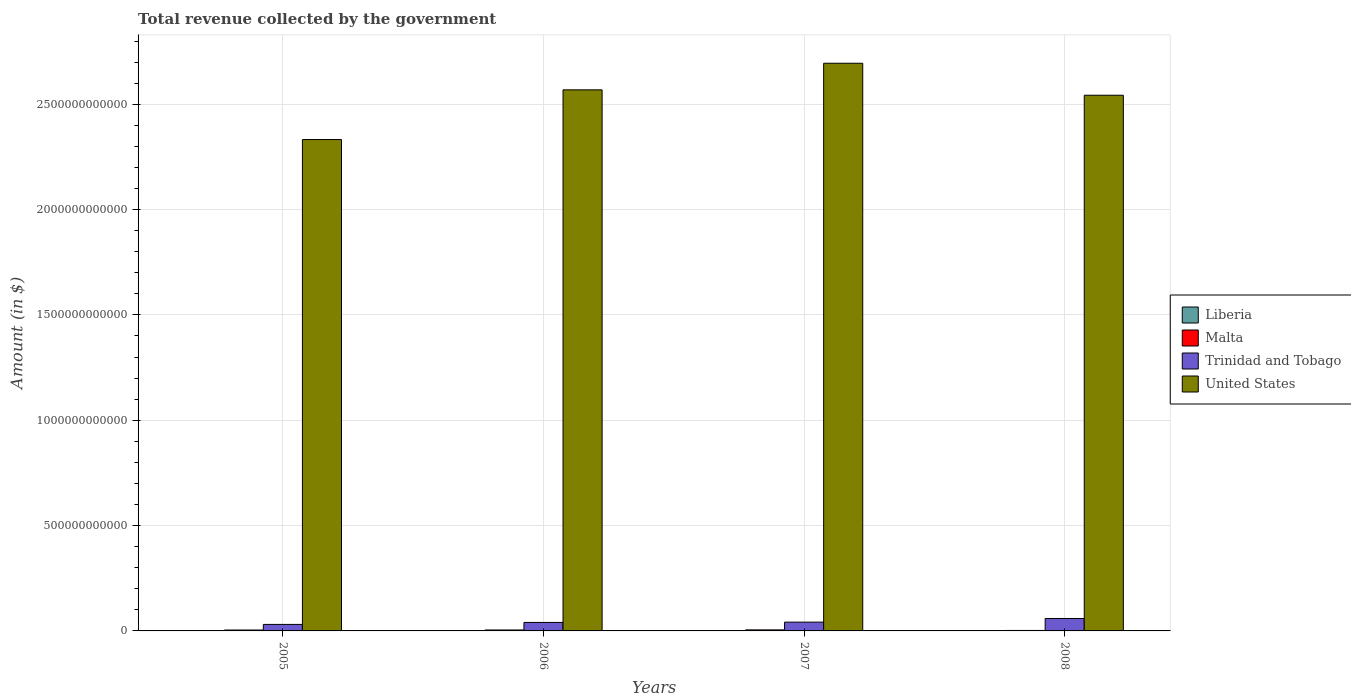How many groups of bars are there?
Offer a very short reply. 4. What is the label of the 1st group of bars from the left?
Your answer should be compact. 2005. What is the total revenue collected by the government in United States in 2007?
Provide a succinct answer. 2.69e+12. Across all years, what is the maximum total revenue collected by the government in Trinidad and Tobago?
Give a very brief answer. 5.90e+1. Across all years, what is the minimum total revenue collected by the government in United States?
Provide a succinct answer. 2.33e+12. What is the total total revenue collected by the government in United States in the graph?
Your response must be concise. 1.01e+13. What is the difference between the total revenue collected by the government in United States in 2005 and that in 2006?
Provide a short and direct response. -2.36e+11. What is the difference between the total revenue collected by the government in Trinidad and Tobago in 2007 and the total revenue collected by the government in Liberia in 2006?
Ensure brevity in your answer.  4.17e+1. What is the average total revenue collected by the government in Malta per year?
Your answer should be compact. 3.98e+09. In the year 2007, what is the difference between the total revenue collected by the government in United States and total revenue collected by the government in Malta?
Give a very brief answer. 2.69e+12. In how many years, is the total revenue collected by the government in United States greater than 1600000000000 $?
Make the answer very short. 4. What is the ratio of the total revenue collected by the government in Malta in 2005 to that in 2008?
Your answer should be compact. 1.89. Is the total revenue collected by the government in Malta in 2005 less than that in 2008?
Offer a very short reply. No. What is the difference between the highest and the second highest total revenue collected by the government in Malta?
Offer a very short reply. 4.26e+08. What is the difference between the highest and the lowest total revenue collected by the government in Trinidad and Tobago?
Offer a very short reply. 2.81e+1. In how many years, is the total revenue collected by the government in Liberia greater than the average total revenue collected by the government in Liberia taken over all years?
Your answer should be compact. 2. Is the sum of the total revenue collected by the government in Liberia in 2006 and 2007 greater than the maximum total revenue collected by the government in United States across all years?
Provide a succinct answer. No. Is it the case that in every year, the sum of the total revenue collected by the government in Liberia and total revenue collected by the government in Malta is greater than the sum of total revenue collected by the government in Trinidad and Tobago and total revenue collected by the government in United States?
Your answer should be compact. No. What does the 2nd bar from the left in 2005 represents?
Make the answer very short. Malta. Is it the case that in every year, the sum of the total revenue collected by the government in United States and total revenue collected by the government in Trinidad and Tobago is greater than the total revenue collected by the government in Malta?
Provide a short and direct response. Yes. How many bars are there?
Offer a terse response. 16. What is the difference between two consecutive major ticks on the Y-axis?
Offer a terse response. 5.00e+11. Does the graph contain any zero values?
Offer a terse response. No. Where does the legend appear in the graph?
Provide a succinct answer. Center right. How are the legend labels stacked?
Your answer should be very brief. Vertical. What is the title of the graph?
Offer a very short reply. Total revenue collected by the government. What is the label or title of the Y-axis?
Give a very brief answer. Amount (in $). What is the Amount (in $) in Liberia in 2005?
Offer a terse response. 1.39e+06. What is the Amount (in $) in Malta in 2005?
Offer a terse response. 4.23e+09. What is the Amount (in $) of Trinidad and Tobago in 2005?
Keep it short and to the point. 3.09e+1. What is the Amount (in $) in United States in 2005?
Make the answer very short. 2.33e+12. What is the Amount (in $) in Liberia in 2006?
Your answer should be very brief. 1.46e+06. What is the Amount (in $) in Malta in 2006?
Provide a succinct answer. 4.51e+09. What is the Amount (in $) in Trinidad and Tobago in 2006?
Give a very brief answer. 4.03e+1. What is the Amount (in $) in United States in 2006?
Offer a terse response. 2.57e+12. What is the Amount (in $) in Liberia in 2007?
Provide a succinct answer. 2.40e+06. What is the Amount (in $) of Malta in 2007?
Your answer should be very brief. 4.93e+09. What is the Amount (in $) in Trinidad and Tobago in 2007?
Offer a very short reply. 4.17e+1. What is the Amount (in $) in United States in 2007?
Ensure brevity in your answer.  2.69e+12. What is the Amount (in $) of Liberia in 2008?
Provide a short and direct response. 3.18e+06. What is the Amount (in $) in Malta in 2008?
Offer a very short reply. 2.24e+09. What is the Amount (in $) of Trinidad and Tobago in 2008?
Provide a short and direct response. 5.90e+1. What is the Amount (in $) of United States in 2008?
Provide a succinct answer. 2.54e+12. Across all years, what is the maximum Amount (in $) in Liberia?
Your response must be concise. 3.18e+06. Across all years, what is the maximum Amount (in $) of Malta?
Give a very brief answer. 4.93e+09. Across all years, what is the maximum Amount (in $) of Trinidad and Tobago?
Your answer should be compact. 5.90e+1. Across all years, what is the maximum Amount (in $) in United States?
Offer a terse response. 2.69e+12. Across all years, what is the minimum Amount (in $) of Liberia?
Your answer should be very brief. 1.39e+06. Across all years, what is the minimum Amount (in $) of Malta?
Ensure brevity in your answer.  2.24e+09. Across all years, what is the minimum Amount (in $) in Trinidad and Tobago?
Your answer should be compact. 3.09e+1. Across all years, what is the minimum Amount (in $) of United States?
Provide a succinct answer. 2.33e+12. What is the total Amount (in $) of Liberia in the graph?
Your answer should be compact. 8.43e+06. What is the total Amount (in $) in Malta in the graph?
Offer a terse response. 1.59e+1. What is the total Amount (in $) of Trinidad and Tobago in the graph?
Ensure brevity in your answer.  1.72e+11. What is the total Amount (in $) of United States in the graph?
Your response must be concise. 1.01e+13. What is the difference between the Amount (in $) in Liberia in 2005 and that in 2006?
Keep it short and to the point. -6.64e+04. What is the difference between the Amount (in $) of Malta in 2005 and that in 2006?
Your response must be concise. -2.75e+08. What is the difference between the Amount (in $) of Trinidad and Tobago in 2005 and that in 2006?
Give a very brief answer. -9.45e+09. What is the difference between the Amount (in $) in United States in 2005 and that in 2006?
Offer a very short reply. -2.36e+11. What is the difference between the Amount (in $) of Liberia in 2005 and that in 2007?
Your response must be concise. -1.01e+06. What is the difference between the Amount (in $) of Malta in 2005 and that in 2007?
Give a very brief answer. -7.01e+08. What is the difference between the Amount (in $) of Trinidad and Tobago in 2005 and that in 2007?
Keep it short and to the point. -1.08e+1. What is the difference between the Amount (in $) in United States in 2005 and that in 2007?
Keep it short and to the point. -3.62e+11. What is the difference between the Amount (in $) in Liberia in 2005 and that in 2008?
Offer a very short reply. -1.79e+06. What is the difference between the Amount (in $) in Malta in 2005 and that in 2008?
Ensure brevity in your answer.  1.99e+09. What is the difference between the Amount (in $) of Trinidad and Tobago in 2005 and that in 2008?
Keep it short and to the point. -2.81e+1. What is the difference between the Amount (in $) of United States in 2005 and that in 2008?
Keep it short and to the point. -2.10e+11. What is the difference between the Amount (in $) of Liberia in 2006 and that in 2007?
Provide a short and direct response. -9.40e+05. What is the difference between the Amount (in $) in Malta in 2006 and that in 2007?
Give a very brief answer. -4.26e+08. What is the difference between the Amount (in $) in Trinidad and Tobago in 2006 and that in 2007?
Give a very brief answer. -1.38e+09. What is the difference between the Amount (in $) of United States in 2006 and that in 2007?
Your response must be concise. -1.26e+11. What is the difference between the Amount (in $) of Liberia in 2006 and that in 2008?
Ensure brevity in your answer.  -1.73e+06. What is the difference between the Amount (in $) in Malta in 2006 and that in 2008?
Keep it short and to the point. 2.27e+09. What is the difference between the Amount (in $) of Trinidad and Tobago in 2006 and that in 2008?
Offer a terse response. -1.87e+1. What is the difference between the Amount (in $) in United States in 2006 and that in 2008?
Give a very brief answer. 2.56e+1. What is the difference between the Amount (in $) in Liberia in 2007 and that in 2008?
Offer a terse response. -7.87e+05. What is the difference between the Amount (in $) in Malta in 2007 and that in 2008?
Ensure brevity in your answer.  2.69e+09. What is the difference between the Amount (in $) in Trinidad and Tobago in 2007 and that in 2008?
Offer a terse response. -1.73e+1. What is the difference between the Amount (in $) of United States in 2007 and that in 2008?
Offer a very short reply. 1.52e+11. What is the difference between the Amount (in $) in Liberia in 2005 and the Amount (in $) in Malta in 2006?
Provide a short and direct response. -4.51e+09. What is the difference between the Amount (in $) in Liberia in 2005 and the Amount (in $) in Trinidad and Tobago in 2006?
Keep it short and to the point. -4.03e+1. What is the difference between the Amount (in $) in Liberia in 2005 and the Amount (in $) in United States in 2006?
Ensure brevity in your answer.  -2.57e+12. What is the difference between the Amount (in $) in Malta in 2005 and the Amount (in $) in Trinidad and Tobago in 2006?
Your response must be concise. -3.61e+1. What is the difference between the Amount (in $) of Malta in 2005 and the Amount (in $) of United States in 2006?
Provide a succinct answer. -2.56e+12. What is the difference between the Amount (in $) in Trinidad and Tobago in 2005 and the Amount (in $) in United States in 2006?
Your answer should be very brief. -2.54e+12. What is the difference between the Amount (in $) in Liberia in 2005 and the Amount (in $) in Malta in 2007?
Ensure brevity in your answer.  -4.93e+09. What is the difference between the Amount (in $) of Liberia in 2005 and the Amount (in $) of Trinidad and Tobago in 2007?
Ensure brevity in your answer.  -4.17e+1. What is the difference between the Amount (in $) of Liberia in 2005 and the Amount (in $) of United States in 2007?
Give a very brief answer. -2.69e+12. What is the difference between the Amount (in $) of Malta in 2005 and the Amount (in $) of Trinidad and Tobago in 2007?
Offer a very short reply. -3.75e+1. What is the difference between the Amount (in $) of Malta in 2005 and the Amount (in $) of United States in 2007?
Provide a short and direct response. -2.69e+12. What is the difference between the Amount (in $) of Trinidad and Tobago in 2005 and the Amount (in $) of United States in 2007?
Ensure brevity in your answer.  -2.66e+12. What is the difference between the Amount (in $) in Liberia in 2005 and the Amount (in $) in Malta in 2008?
Your answer should be compact. -2.24e+09. What is the difference between the Amount (in $) in Liberia in 2005 and the Amount (in $) in Trinidad and Tobago in 2008?
Your response must be concise. -5.90e+1. What is the difference between the Amount (in $) of Liberia in 2005 and the Amount (in $) of United States in 2008?
Offer a very short reply. -2.54e+12. What is the difference between the Amount (in $) of Malta in 2005 and the Amount (in $) of Trinidad and Tobago in 2008?
Your answer should be compact. -5.48e+1. What is the difference between the Amount (in $) in Malta in 2005 and the Amount (in $) in United States in 2008?
Keep it short and to the point. -2.54e+12. What is the difference between the Amount (in $) in Trinidad and Tobago in 2005 and the Amount (in $) in United States in 2008?
Provide a short and direct response. -2.51e+12. What is the difference between the Amount (in $) of Liberia in 2006 and the Amount (in $) of Malta in 2007?
Give a very brief answer. -4.93e+09. What is the difference between the Amount (in $) of Liberia in 2006 and the Amount (in $) of Trinidad and Tobago in 2007?
Ensure brevity in your answer.  -4.17e+1. What is the difference between the Amount (in $) in Liberia in 2006 and the Amount (in $) in United States in 2007?
Your answer should be compact. -2.69e+12. What is the difference between the Amount (in $) of Malta in 2006 and the Amount (in $) of Trinidad and Tobago in 2007?
Your answer should be compact. -3.72e+1. What is the difference between the Amount (in $) of Malta in 2006 and the Amount (in $) of United States in 2007?
Make the answer very short. -2.69e+12. What is the difference between the Amount (in $) in Trinidad and Tobago in 2006 and the Amount (in $) in United States in 2007?
Provide a succinct answer. -2.65e+12. What is the difference between the Amount (in $) in Liberia in 2006 and the Amount (in $) in Malta in 2008?
Provide a succinct answer. -2.24e+09. What is the difference between the Amount (in $) in Liberia in 2006 and the Amount (in $) in Trinidad and Tobago in 2008?
Ensure brevity in your answer.  -5.90e+1. What is the difference between the Amount (in $) in Liberia in 2006 and the Amount (in $) in United States in 2008?
Your response must be concise. -2.54e+12. What is the difference between the Amount (in $) of Malta in 2006 and the Amount (in $) of Trinidad and Tobago in 2008?
Provide a succinct answer. -5.45e+1. What is the difference between the Amount (in $) of Malta in 2006 and the Amount (in $) of United States in 2008?
Offer a very short reply. -2.54e+12. What is the difference between the Amount (in $) of Trinidad and Tobago in 2006 and the Amount (in $) of United States in 2008?
Keep it short and to the point. -2.50e+12. What is the difference between the Amount (in $) in Liberia in 2007 and the Amount (in $) in Malta in 2008?
Your answer should be very brief. -2.24e+09. What is the difference between the Amount (in $) in Liberia in 2007 and the Amount (in $) in Trinidad and Tobago in 2008?
Offer a terse response. -5.90e+1. What is the difference between the Amount (in $) of Liberia in 2007 and the Amount (in $) of United States in 2008?
Your answer should be compact. -2.54e+12. What is the difference between the Amount (in $) in Malta in 2007 and the Amount (in $) in Trinidad and Tobago in 2008?
Offer a very short reply. -5.41e+1. What is the difference between the Amount (in $) of Malta in 2007 and the Amount (in $) of United States in 2008?
Offer a terse response. -2.54e+12. What is the difference between the Amount (in $) in Trinidad and Tobago in 2007 and the Amount (in $) in United States in 2008?
Your response must be concise. -2.50e+12. What is the average Amount (in $) in Liberia per year?
Make the answer very short. 2.11e+06. What is the average Amount (in $) of Malta per year?
Provide a succinct answer. 3.98e+09. What is the average Amount (in $) in Trinidad and Tobago per year?
Your answer should be compact. 4.30e+1. What is the average Amount (in $) in United States per year?
Provide a succinct answer. 2.53e+12. In the year 2005, what is the difference between the Amount (in $) in Liberia and Amount (in $) in Malta?
Keep it short and to the point. -4.23e+09. In the year 2005, what is the difference between the Amount (in $) of Liberia and Amount (in $) of Trinidad and Tobago?
Offer a terse response. -3.09e+1. In the year 2005, what is the difference between the Amount (in $) of Liberia and Amount (in $) of United States?
Offer a very short reply. -2.33e+12. In the year 2005, what is the difference between the Amount (in $) of Malta and Amount (in $) of Trinidad and Tobago?
Give a very brief answer. -2.66e+1. In the year 2005, what is the difference between the Amount (in $) in Malta and Amount (in $) in United States?
Provide a short and direct response. -2.33e+12. In the year 2005, what is the difference between the Amount (in $) in Trinidad and Tobago and Amount (in $) in United States?
Your answer should be compact. -2.30e+12. In the year 2006, what is the difference between the Amount (in $) in Liberia and Amount (in $) in Malta?
Your answer should be very brief. -4.51e+09. In the year 2006, what is the difference between the Amount (in $) of Liberia and Amount (in $) of Trinidad and Tobago?
Give a very brief answer. -4.03e+1. In the year 2006, what is the difference between the Amount (in $) in Liberia and Amount (in $) in United States?
Offer a very short reply. -2.57e+12. In the year 2006, what is the difference between the Amount (in $) in Malta and Amount (in $) in Trinidad and Tobago?
Your answer should be very brief. -3.58e+1. In the year 2006, what is the difference between the Amount (in $) of Malta and Amount (in $) of United States?
Ensure brevity in your answer.  -2.56e+12. In the year 2006, what is the difference between the Amount (in $) of Trinidad and Tobago and Amount (in $) of United States?
Provide a short and direct response. -2.53e+12. In the year 2007, what is the difference between the Amount (in $) in Liberia and Amount (in $) in Malta?
Ensure brevity in your answer.  -4.93e+09. In the year 2007, what is the difference between the Amount (in $) in Liberia and Amount (in $) in Trinidad and Tobago?
Your answer should be very brief. -4.17e+1. In the year 2007, what is the difference between the Amount (in $) in Liberia and Amount (in $) in United States?
Make the answer very short. -2.69e+12. In the year 2007, what is the difference between the Amount (in $) of Malta and Amount (in $) of Trinidad and Tobago?
Ensure brevity in your answer.  -3.68e+1. In the year 2007, what is the difference between the Amount (in $) in Malta and Amount (in $) in United States?
Offer a very short reply. -2.69e+12. In the year 2007, what is the difference between the Amount (in $) in Trinidad and Tobago and Amount (in $) in United States?
Make the answer very short. -2.65e+12. In the year 2008, what is the difference between the Amount (in $) of Liberia and Amount (in $) of Malta?
Ensure brevity in your answer.  -2.24e+09. In the year 2008, what is the difference between the Amount (in $) in Liberia and Amount (in $) in Trinidad and Tobago?
Offer a very short reply. -5.90e+1. In the year 2008, what is the difference between the Amount (in $) in Liberia and Amount (in $) in United States?
Keep it short and to the point. -2.54e+12. In the year 2008, what is the difference between the Amount (in $) in Malta and Amount (in $) in Trinidad and Tobago?
Give a very brief answer. -5.67e+1. In the year 2008, what is the difference between the Amount (in $) of Malta and Amount (in $) of United States?
Give a very brief answer. -2.54e+12. In the year 2008, what is the difference between the Amount (in $) of Trinidad and Tobago and Amount (in $) of United States?
Offer a terse response. -2.48e+12. What is the ratio of the Amount (in $) of Liberia in 2005 to that in 2006?
Give a very brief answer. 0.95. What is the ratio of the Amount (in $) of Malta in 2005 to that in 2006?
Offer a very short reply. 0.94. What is the ratio of the Amount (in $) in Trinidad and Tobago in 2005 to that in 2006?
Provide a short and direct response. 0.77. What is the ratio of the Amount (in $) in United States in 2005 to that in 2006?
Provide a succinct answer. 0.91. What is the ratio of the Amount (in $) in Liberia in 2005 to that in 2007?
Provide a short and direct response. 0.58. What is the ratio of the Amount (in $) in Malta in 2005 to that in 2007?
Make the answer very short. 0.86. What is the ratio of the Amount (in $) of Trinidad and Tobago in 2005 to that in 2007?
Provide a succinct answer. 0.74. What is the ratio of the Amount (in $) of United States in 2005 to that in 2007?
Provide a succinct answer. 0.87. What is the ratio of the Amount (in $) in Liberia in 2005 to that in 2008?
Make the answer very short. 0.44. What is the ratio of the Amount (in $) of Malta in 2005 to that in 2008?
Your answer should be very brief. 1.89. What is the ratio of the Amount (in $) of Trinidad and Tobago in 2005 to that in 2008?
Offer a terse response. 0.52. What is the ratio of the Amount (in $) in United States in 2005 to that in 2008?
Your response must be concise. 0.92. What is the ratio of the Amount (in $) of Liberia in 2006 to that in 2007?
Make the answer very short. 0.61. What is the ratio of the Amount (in $) in Malta in 2006 to that in 2007?
Offer a terse response. 0.91. What is the ratio of the Amount (in $) of Trinidad and Tobago in 2006 to that in 2007?
Provide a succinct answer. 0.97. What is the ratio of the Amount (in $) of United States in 2006 to that in 2007?
Your response must be concise. 0.95. What is the ratio of the Amount (in $) in Liberia in 2006 to that in 2008?
Provide a short and direct response. 0.46. What is the ratio of the Amount (in $) in Malta in 2006 to that in 2008?
Your answer should be compact. 2.01. What is the ratio of the Amount (in $) of Trinidad and Tobago in 2006 to that in 2008?
Provide a succinct answer. 0.68. What is the ratio of the Amount (in $) in Liberia in 2007 to that in 2008?
Make the answer very short. 0.75. What is the ratio of the Amount (in $) of Malta in 2007 to that in 2008?
Provide a succinct answer. 2.2. What is the ratio of the Amount (in $) in Trinidad and Tobago in 2007 to that in 2008?
Offer a very short reply. 0.71. What is the ratio of the Amount (in $) of United States in 2007 to that in 2008?
Provide a short and direct response. 1.06. What is the difference between the highest and the second highest Amount (in $) in Liberia?
Give a very brief answer. 7.87e+05. What is the difference between the highest and the second highest Amount (in $) of Malta?
Ensure brevity in your answer.  4.26e+08. What is the difference between the highest and the second highest Amount (in $) of Trinidad and Tobago?
Make the answer very short. 1.73e+1. What is the difference between the highest and the second highest Amount (in $) of United States?
Keep it short and to the point. 1.26e+11. What is the difference between the highest and the lowest Amount (in $) in Liberia?
Your response must be concise. 1.79e+06. What is the difference between the highest and the lowest Amount (in $) of Malta?
Make the answer very short. 2.69e+09. What is the difference between the highest and the lowest Amount (in $) in Trinidad and Tobago?
Provide a succinct answer. 2.81e+1. What is the difference between the highest and the lowest Amount (in $) of United States?
Offer a terse response. 3.62e+11. 